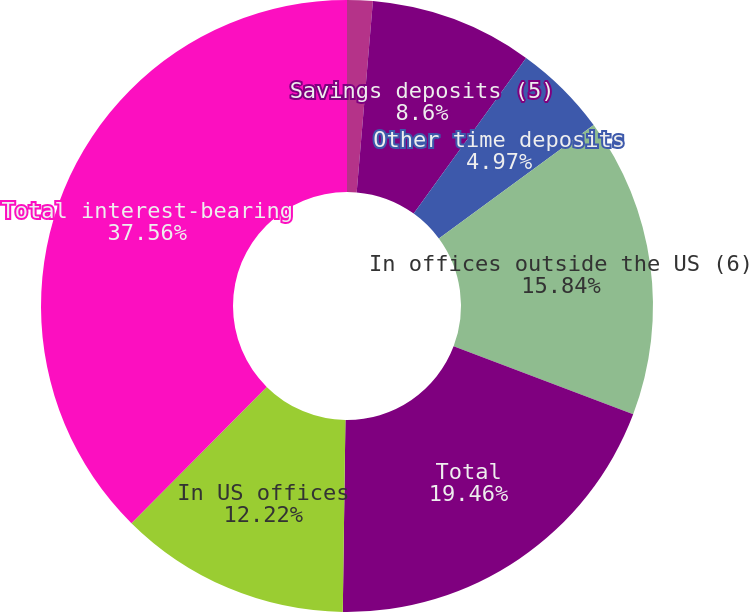<chart> <loc_0><loc_0><loc_500><loc_500><pie_chart><fcel>In millions of dollars<fcel>Savings deposits (5)<fcel>Other time deposits<fcel>In offices outside the US (6)<fcel>Total<fcel>In US offices<fcel>Total interest-bearing<nl><fcel>1.35%<fcel>8.6%<fcel>4.97%<fcel>15.84%<fcel>19.46%<fcel>12.22%<fcel>37.56%<nl></chart> 